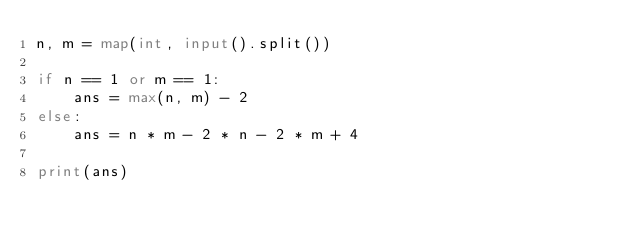Convert code to text. <code><loc_0><loc_0><loc_500><loc_500><_Python_>n, m = map(int, input().split())

if n == 1 or m == 1:
    ans = max(n, m) - 2
else:
    ans = n * m - 2 * n - 2 * m + 4

print(ans)
</code> 